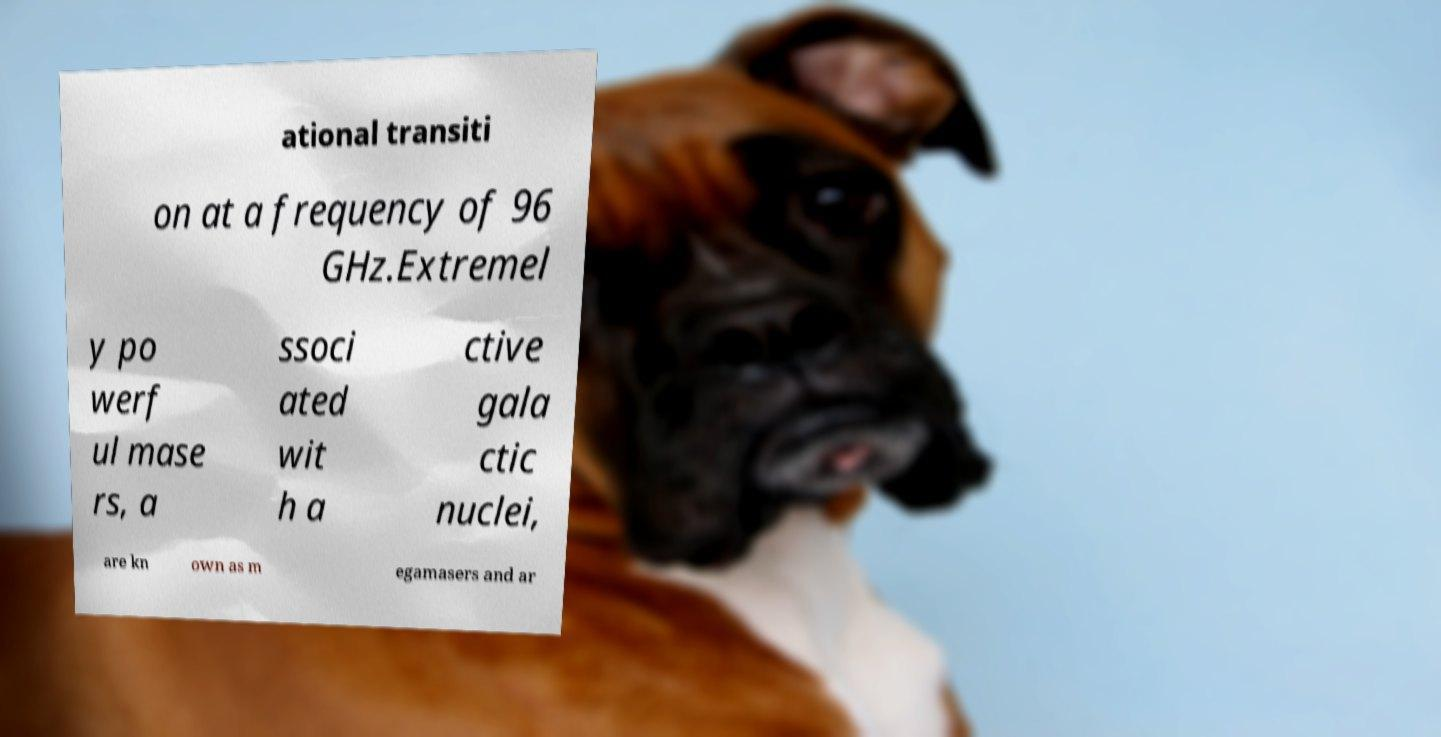Please read and relay the text visible in this image. What does it say? ational transiti on at a frequency of 96 GHz.Extremel y po werf ul mase rs, a ssoci ated wit h a ctive gala ctic nuclei, are kn own as m egamasers and ar 